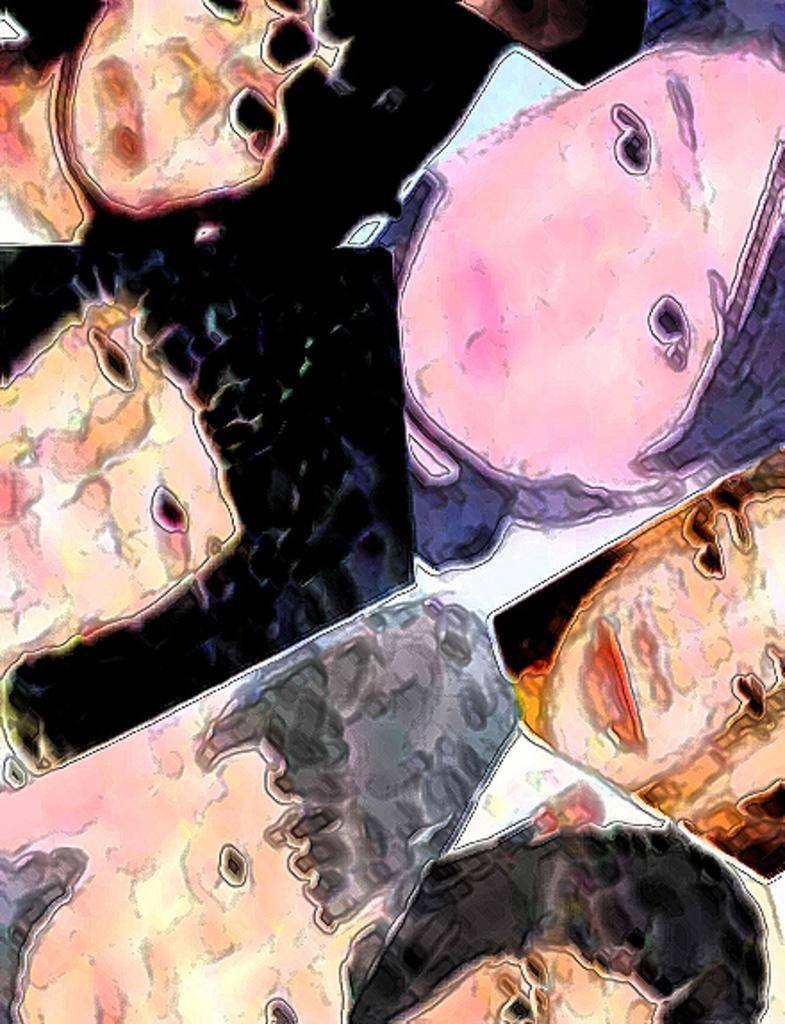What can be observed about the image? The image is edited. What can be seen in the edited image? The faces of people are visible in the image. Can you see a zipper on any of the faces in the image? There is no zipper present on any of the faces in the image. Are there any nests visible in the image? There are no nests visible in the image. How many frogs can be seen in the image? There are no frogs present in the image. 